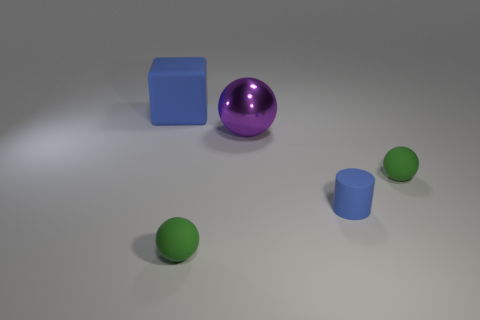What kind of lighting is used in the scene, and what effect does it have on the objects? The scene is illuminated with what appears to be a single overhead light source, creating soft shadows on the ground beneath each object. This lighting casts a gentle gradient of brightness across the scene, highlighting the curvature and surfaces of the objects while giving the entire composition a calm and balanced atmosphere. 